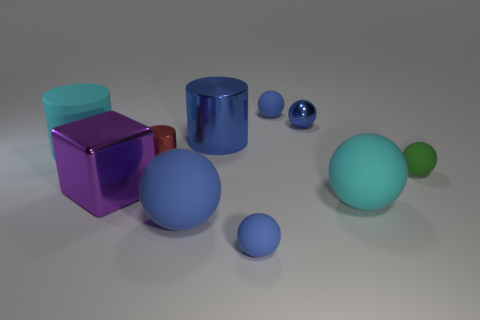Are there any other things that have the same shape as the green thing?
Your answer should be very brief. Yes. Are there the same number of large cyan spheres to the left of the big purple cube and big green things?
Offer a very short reply. Yes. What number of large things are on the left side of the large blue metallic cylinder and to the right of the cyan cylinder?
Offer a very short reply. 2. What is the size of the green object that is the same shape as the tiny blue metal object?
Keep it short and to the point. Small. What number of green things are made of the same material as the red object?
Provide a succinct answer. 0. Are there fewer purple metallic objects behind the red metal cylinder than big brown matte blocks?
Your answer should be very brief. No. What number of large blue objects are there?
Your response must be concise. 2. How many matte objects have the same color as the metal ball?
Your response must be concise. 3. Do the green thing and the large blue matte object have the same shape?
Your answer should be compact. Yes. What is the size of the cyan object that is right of the tiny shiny object that is behind the small metal cylinder?
Offer a terse response. Large. 